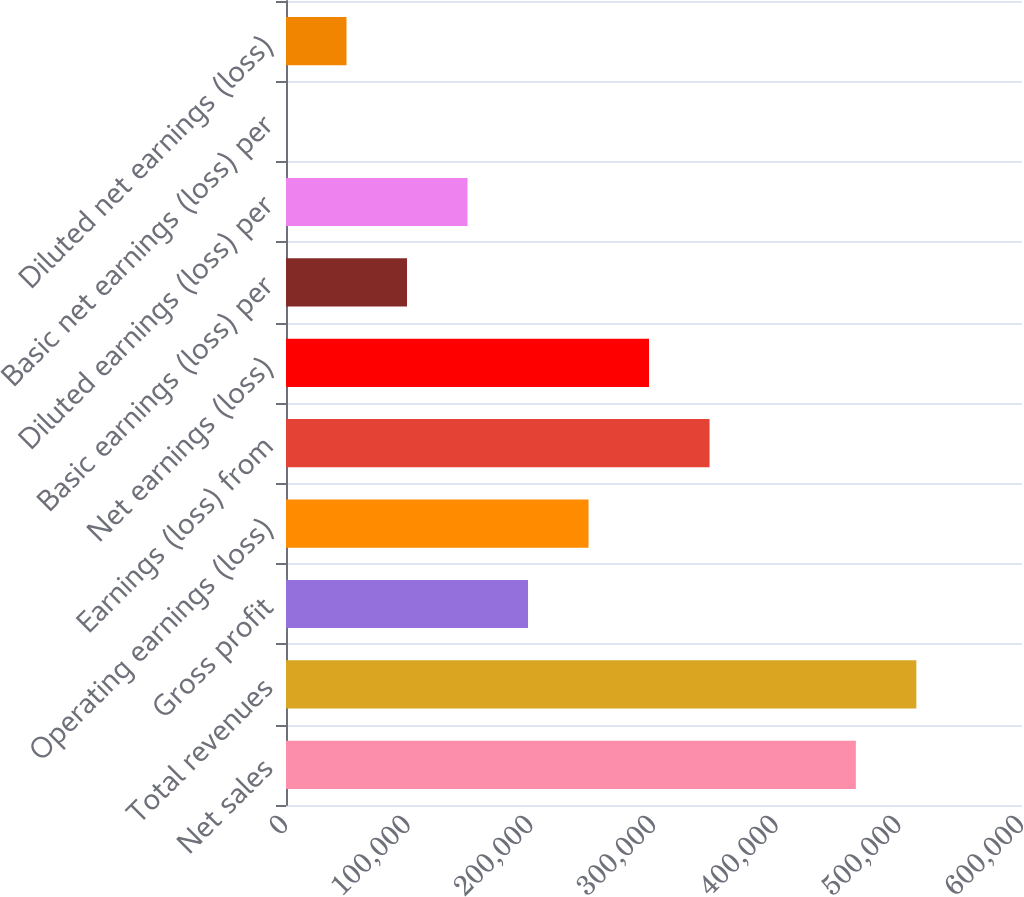Convert chart. <chart><loc_0><loc_0><loc_500><loc_500><bar_chart><fcel>Net sales<fcel>Total revenues<fcel>Gross profit<fcel>Operating earnings (loss)<fcel>Earnings (loss) from<fcel>Net earnings (loss)<fcel>Basic earnings (loss) per<fcel>Diluted earnings (loss) per<fcel>Basic net earnings (loss) per<fcel>Diluted net earnings (loss)<nl><fcel>464534<fcel>513860<fcel>197306<fcel>246632<fcel>345285<fcel>295959<fcel>98653.1<fcel>147979<fcel>0.31<fcel>49326.7<nl></chart> 